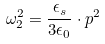Convert formula to latex. <formula><loc_0><loc_0><loc_500><loc_500>\omega _ { 2 } ^ { 2 } = \frac { \epsilon _ { s } } { 3 \epsilon _ { 0 } } \cdot { p } ^ { 2 }</formula> 